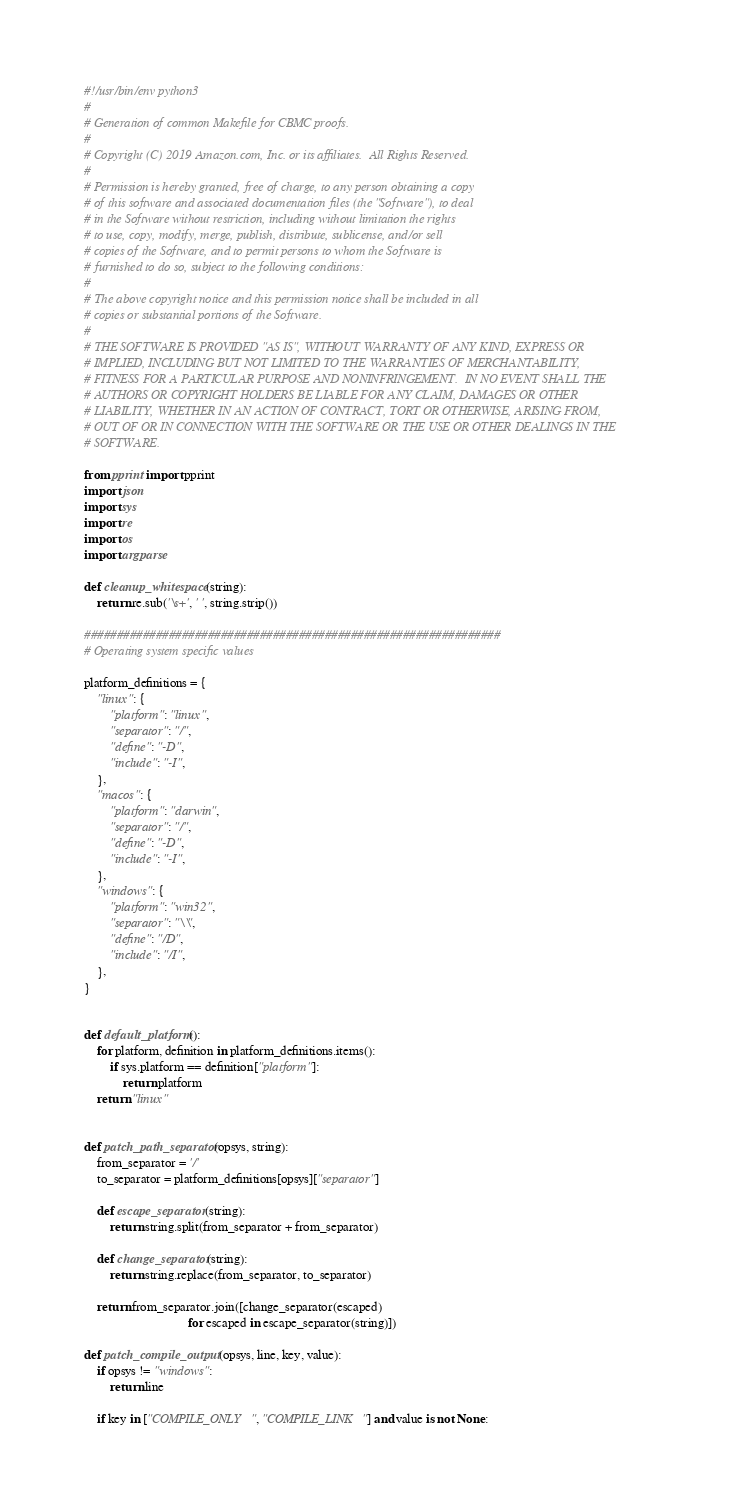Convert code to text. <code><loc_0><loc_0><loc_500><loc_500><_Python_>#!/usr/bin/env python3
#
# Generation of common Makefile for CBMC proofs.
#
# Copyright (C) 2019 Amazon.com, Inc. or its affiliates.  All Rights Reserved.
#
# Permission is hereby granted, free of charge, to any person obtaining a copy
# of this software and associated documentation files (the "Software"), to deal
# in the Software without restriction, including without limitation the rights
# to use, copy, modify, merge, publish, distribute, sublicense, and/or sell
# copies of the Software, and to permit persons to whom the Software is
# furnished to do so, subject to the following conditions:
#
# The above copyright notice and this permission notice shall be included in all
# copies or substantial portions of the Software.
#
# THE SOFTWARE IS PROVIDED "AS IS", WITHOUT WARRANTY OF ANY KIND, EXPRESS OR
# IMPLIED, INCLUDING BUT NOT LIMITED TO THE WARRANTIES OF MERCHANTABILITY,
# FITNESS FOR A PARTICULAR PURPOSE AND NONINFRINGEMENT.  IN NO EVENT SHALL THE
# AUTHORS OR COPYRIGHT HOLDERS BE LIABLE FOR ANY CLAIM, DAMAGES OR OTHER
# LIABILITY, WHETHER IN AN ACTION OF CONTRACT, TORT OR OTHERWISE, ARISING FROM,
# OUT OF OR IN CONNECTION WITH THE SOFTWARE OR THE USE OR OTHER DEALINGS IN THE
# SOFTWARE.

from pprint import pprint
import json
import sys
import re
import os
import argparse

def cleanup_whitespace(string):
    return re.sub('\s+', ' ', string.strip())

################################################################
# Operating system specific values

platform_definitions = {
    "linux": {
        "platform": "linux",
        "separator": "/",
        "define": "-D",
        "include": "-I",
    },
    "macos": {
        "platform": "darwin",
        "separator": "/",
        "define": "-D",
        "include": "-I",
    },
    "windows": {
        "platform": "win32",
        "separator": "\\",
        "define": "/D",
        "include": "/I",
    },
}


def default_platform():
    for platform, definition in platform_definitions.items():
        if sys.platform == definition["platform"]:
            return platform
    return "linux"


def patch_path_separator(opsys, string):
    from_separator = '/'
    to_separator = platform_definitions[opsys]["separator"]

    def escape_separator(string):
        return string.split(from_separator + from_separator)

    def change_separator(string):
        return string.replace(from_separator, to_separator)

    return from_separator.join([change_separator(escaped)
                                for escaped in escape_separator(string)])

def patch_compile_output(opsys, line, key, value):
    if opsys != "windows":
        return line

    if key in ["COMPILE_ONLY", "COMPILE_LINK"] and value is not None:</code> 